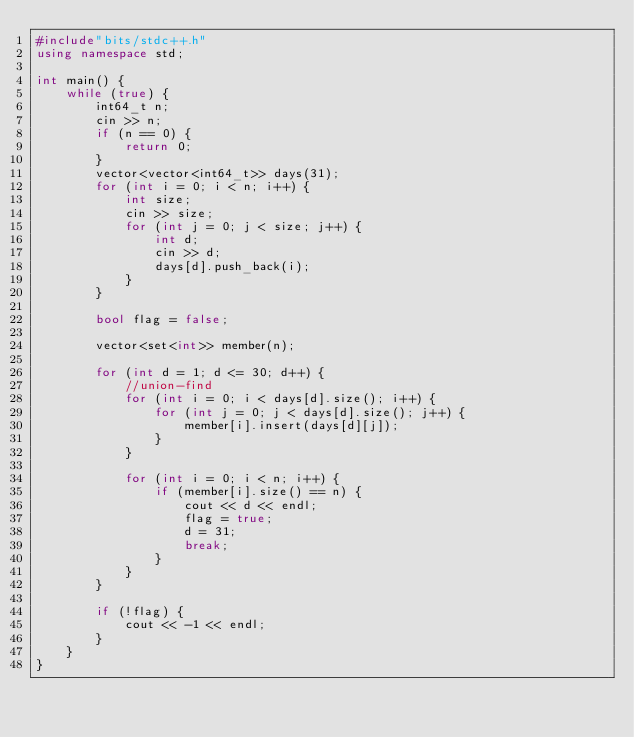<code> <loc_0><loc_0><loc_500><loc_500><_C++_>#include"bits/stdc++.h"
using namespace std;

int main() {
    while (true) {
        int64_t n;
        cin >> n;
        if (n == 0) {
            return 0;
        }
        vector<vector<int64_t>> days(31);
        for (int i = 0; i < n; i++) {
            int size;
            cin >> size;
            for (int j = 0; j < size; j++) {
                int d;
                cin >> d;
                days[d].push_back(i);
            }
        }

        bool flag = false;

        vector<set<int>> member(n);

        for (int d = 1; d <= 30; d++) {
            //union-find
            for (int i = 0; i < days[d].size(); i++) {
                for (int j = 0; j < days[d].size(); j++) {
                    member[i].insert(days[d][j]);
                }
            }

            for (int i = 0; i < n; i++) {
                if (member[i].size() == n) {
                    cout << d << endl;
                    flag = true;
                    d = 31;
                    break;
                }
            }
        }

        if (!flag) {
            cout << -1 << endl;
        }
    }
}
</code> 